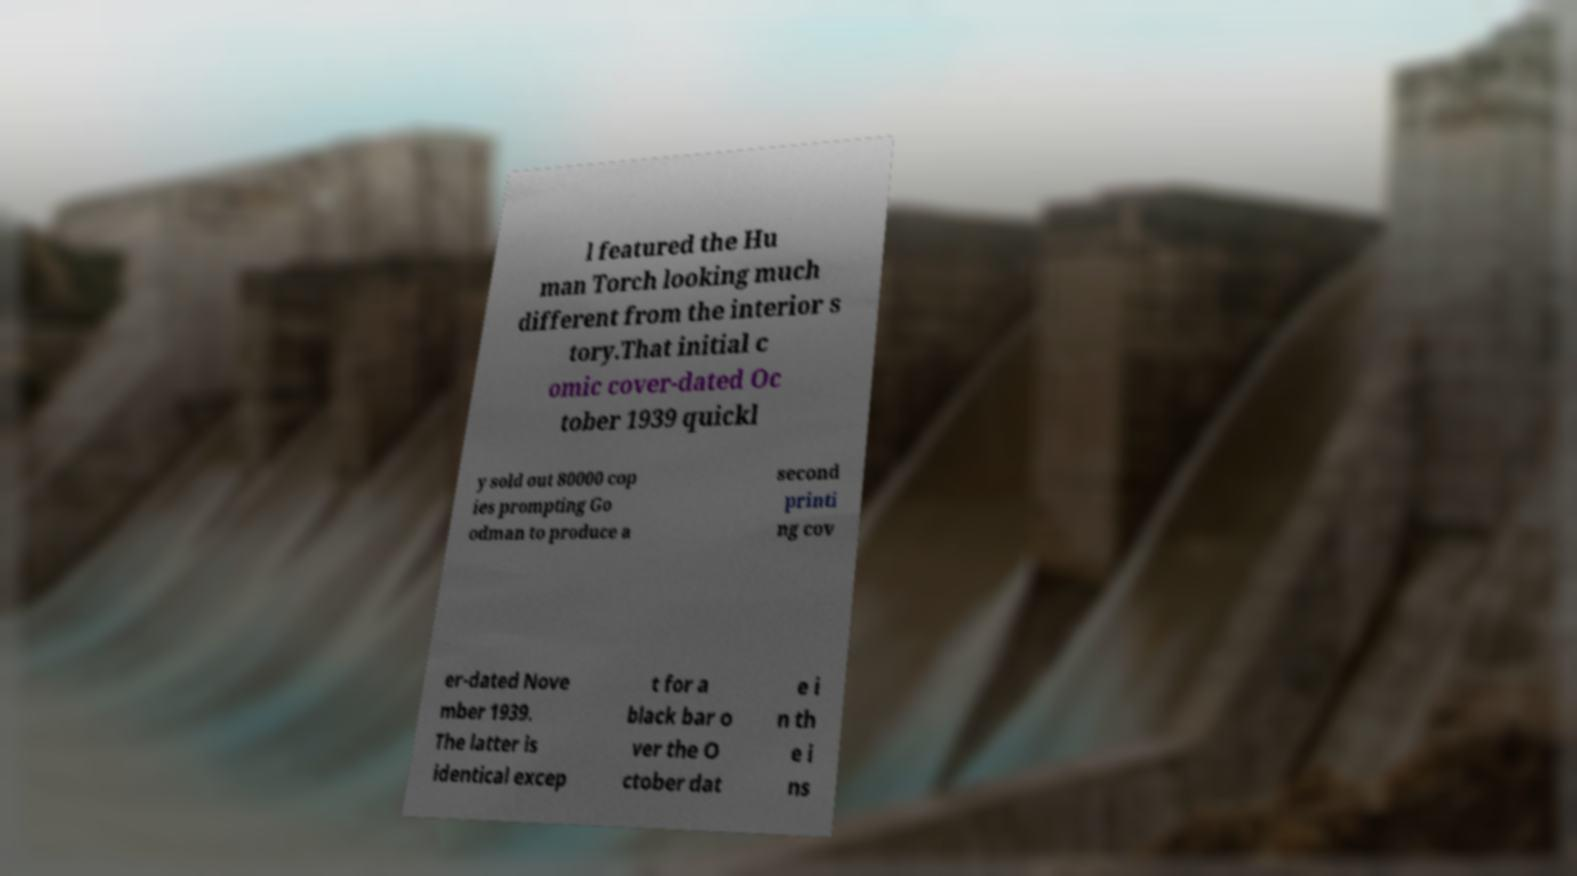I need the written content from this picture converted into text. Can you do that? l featured the Hu man Torch looking much different from the interior s tory.That initial c omic cover-dated Oc tober 1939 quickl y sold out 80000 cop ies prompting Go odman to produce a second printi ng cov er-dated Nove mber 1939. The latter is identical excep t for a black bar o ver the O ctober dat e i n th e i ns 